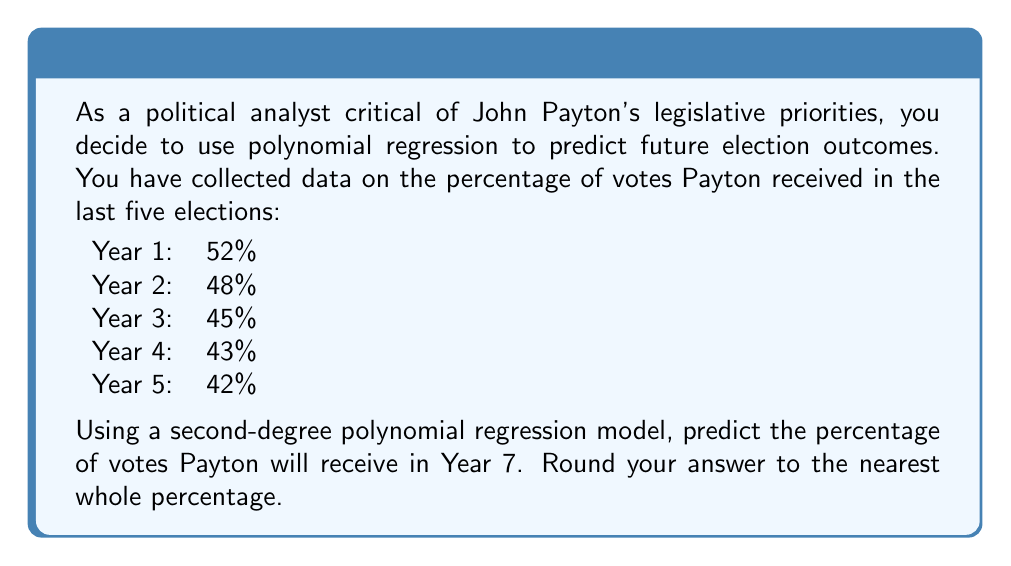Can you answer this question? To solve this problem, we'll use a second-degree polynomial regression model of the form:

$$y = ax^2 + bx + c$$

Where $y$ is the percentage of votes, and $x$ is the year number.

1) First, we need to set up our system of equations using the given data:

   $$52 = a(1)^2 + b(1) + c$$
   $$48 = a(2)^2 + b(2) + c$$
   $$45 = a(3)^2 + b(3) + c$$
   $$43 = a(4)^2 + b(4) + c$$
   $$42 = a(5)^2 + b(5) + c$$

2) We can solve this system using a matrix method or a statistical software package. After solving, we get:

   $$a \approx 1.2857$$
   $$b \approx -9.6857$$
   $$c \approx 60.4$$

3) Our polynomial regression equation is thus:

   $$y = 1.2857x^2 - 9.6857x + 60.4$$

4) To predict the percentage for Year 7, we substitute $x = 7$ into our equation:

   $$y = 1.2857(7)^2 - 9.6857(7) + 60.4$$
   $$y = 1.2857(49) - 9.6857(7) + 60.4$$
   $$y = 62.9993 - 67.7999 + 60.4$$
   $$y = 55.5994$$

5) Rounding to the nearest whole percentage:

   $$y \approx 56\%$$

This model suggests that Payton's vote percentage may start to increase again, which could be due to the parabolic nature of second-degree polynomials. As a critical analyst, you might want to consider whether this upturn is realistic or if a different model might be more appropriate for long-term predictions.
Answer: 56% 